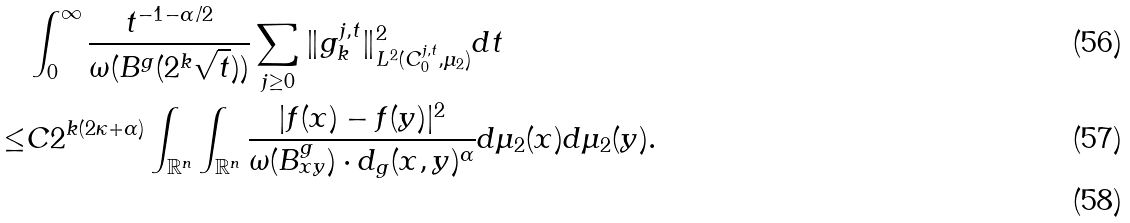Convert formula to latex. <formula><loc_0><loc_0><loc_500><loc_500>& \int _ { 0 } ^ { \infty } \frac { t ^ { - 1 - \alpha / 2 } } { \omega ( B ^ { g } ( 2 ^ { k } \sqrt { t } ) ) } \sum _ { j \geq 0 } \| g _ { k } ^ { j , t } \| ^ { 2 } _ { L ^ { 2 } ( C _ { 0 } ^ { j , t } , \mu _ { 2 } ) } d t \\ \leq & C 2 ^ { k ( 2 \kappa + \alpha ) } \int _ { \mathbb { R } ^ { n } } \int _ { \mathbb { R } ^ { n } } \frac { | f ( x ) - f ( y ) | ^ { 2 } } { \omega ( B ^ { g } _ { x y } ) \cdot d _ { g } ( x , y ) ^ { \alpha } } d \mu _ { 2 } ( x ) d \mu _ { 2 } ( y ) . \\</formula> 